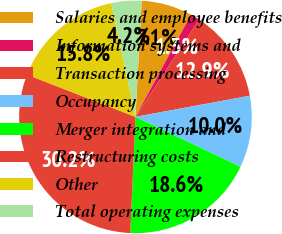Convert chart to OTSL. <chart><loc_0><loc_0><loc_500><loc_500><pie_chart><fcel>Salaries and employee benefits<fcel>Information systems and<fcel>Transaction processing<fcel>Occupancy<fcel>Merger integration and<fcel>Restructuring costs<fcel>Other<fcel>Total operating expenses<nl><fcel>7.08%<fcel>1.3%<fcel>12.86%<fcel>9.97%<fcel>18.64%<fcel>30.2%<fcel>15.75%<fcel>4.19%<nl></chart> 